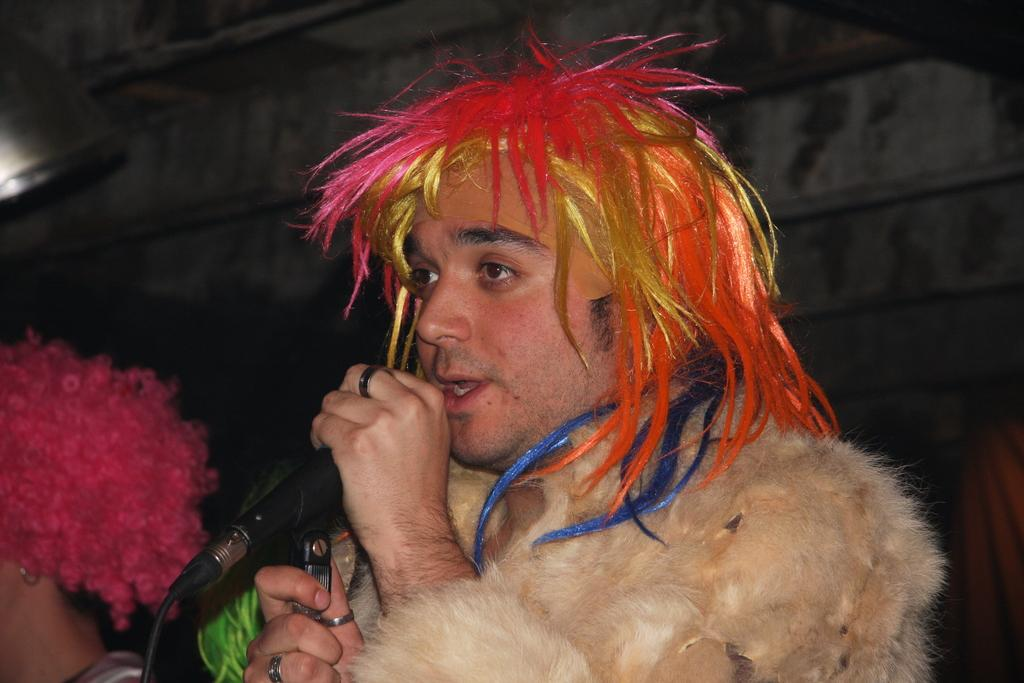What is the appearance of the man's hair in the image? The man has colored hair in the image. What is the man holding in the image? The man is holding a microphone. What can be seen behind the man in the image? There is a plain wall in the background of the image. Can you describe the other person in the image? There is another person in the image on the left side. Is the man standing in quicksand in the image? No, the man is not standing in quicksand in the image; he is standing on a solid surface. What type of brick is being used to build the wall in the image? There is no brick visible in the image, as the wall in the background is plain. 